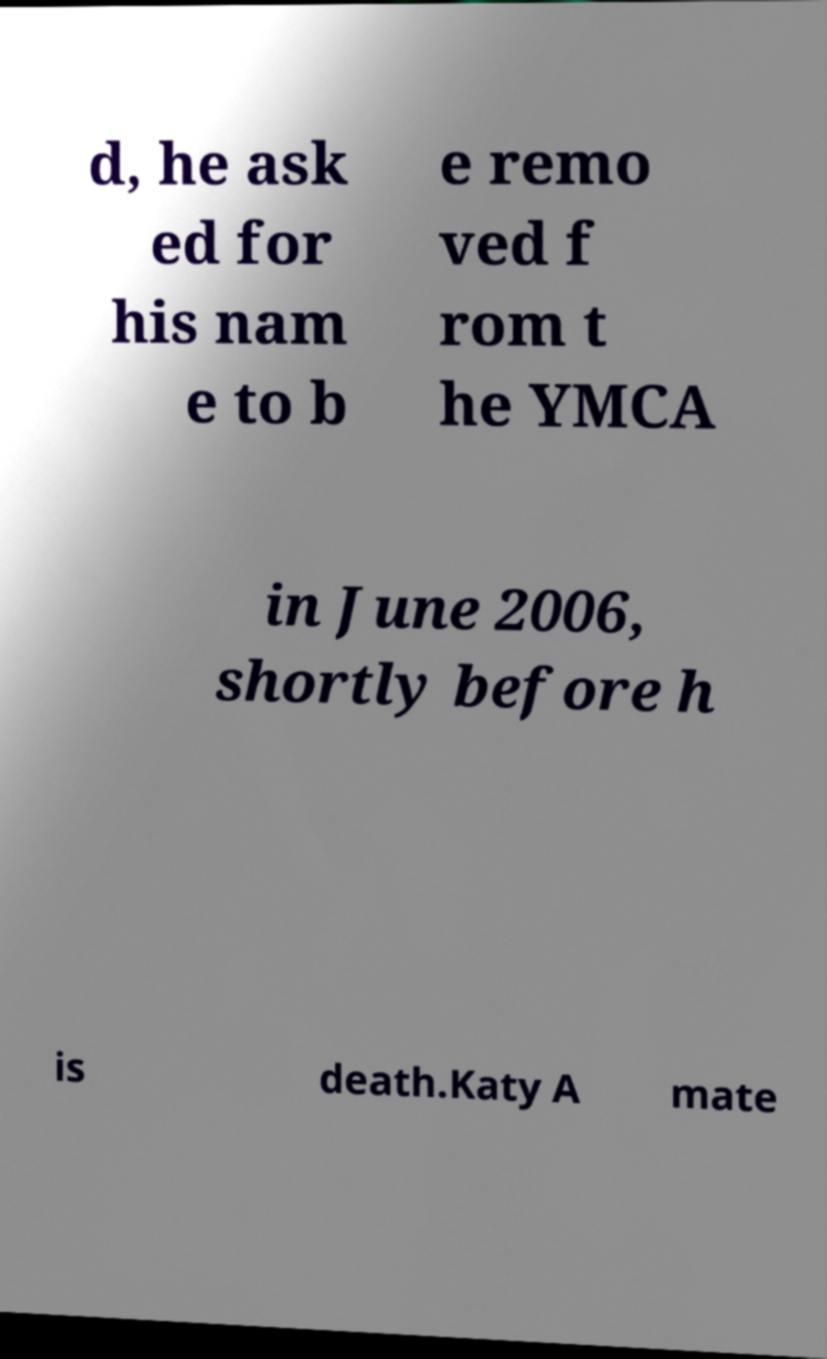Please identify and transcribe the text found in this image. d, he ask ed for his nam e to b e remo ved f rom t he YMCA in June 2006, shortly before h is death.Katy A mate 